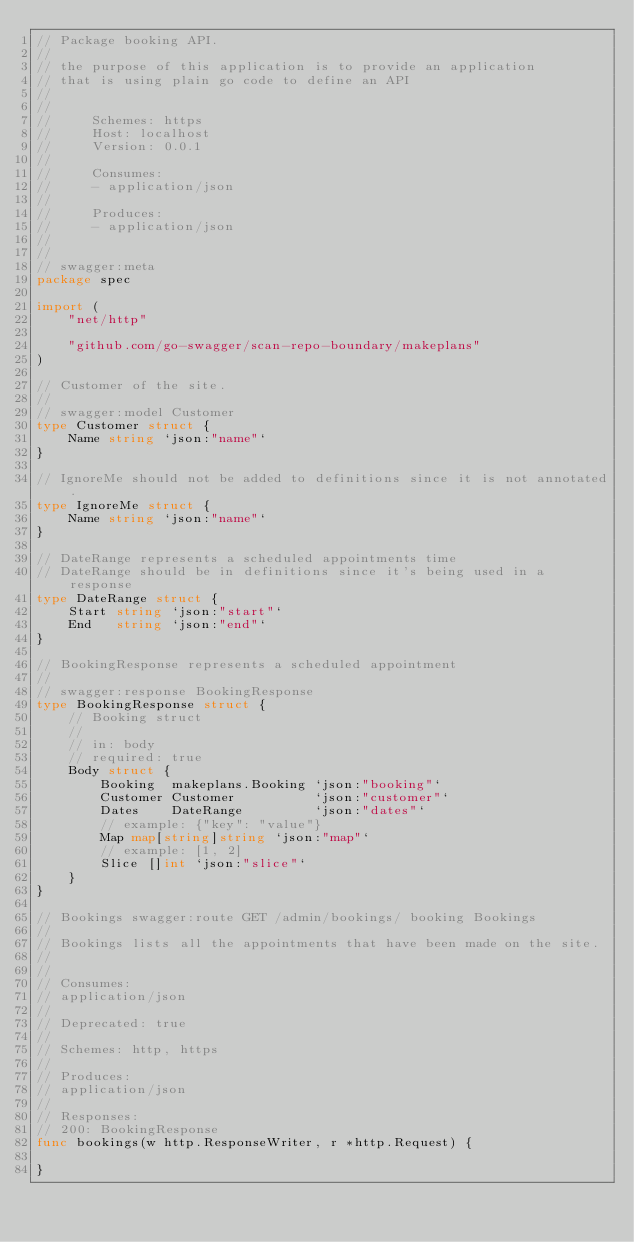<code> <loc_0><loc_0><loc_500><loc_500><_Go_>// Package booking API.
//
// the purpose of this application is to provide an application
// that is using plain go code to define an API
//
//
//     Schemes: https
//     Host: localhost
//     Version: 0.0.1
//
//     Consumes:
//     - application/json
//
//     Produces:
//     - application/json
//
//
// swagger:meta
package spec

import (
	"net/http"

	"github.com/go-swagger/scan-repo-boundary/makeplans"
)

// Customer of the site.
//
// swagger:model Customer
type Customer struct {
	Name string `json:"name"`
}

// IgnoreMe should not be added to definitions since it is not annotated.
type IgnoreMe struct {
	Name string `json:"name"`
}

// DateRange represents a scheduled appointments time
// DateRange should be in definitions since it's being used in a response
type DateRange struct {
	Start string `json:"start"`
	End   string `json:"end"`
}

// BookingResponse represents a scheduled appointment
//
// swagger:response BookingResponse
type BookingResponse struct {
	// Booking struct
	//
	// in: body
	// required: true
	Body struct {
		Booking  makeplans.Booking `json:"booking"`
		Customer Customer          `json:"customer"`
		Dates    DateRange         `json:"dates"`
		// example: {"key": "value"}
		Map map[string]string `json:"map"`
		// example: [1, 2]
		Slice []int `json:"slice"`
	}
}

// Bookings swagger:route GET /admin/bookings/ booking Bookings
//
// Bookings lists all the appointments that have been made on the site.
//
//
// Consumes:
// application/json
//
// Deprecated: true
//
// Schemes: http, https
//
// Produces:
// application/json
//
// Responses:
// 200: BookingResponse
func bookings(w http.ResponseWriter, r *http.Request) {

}
</code> 